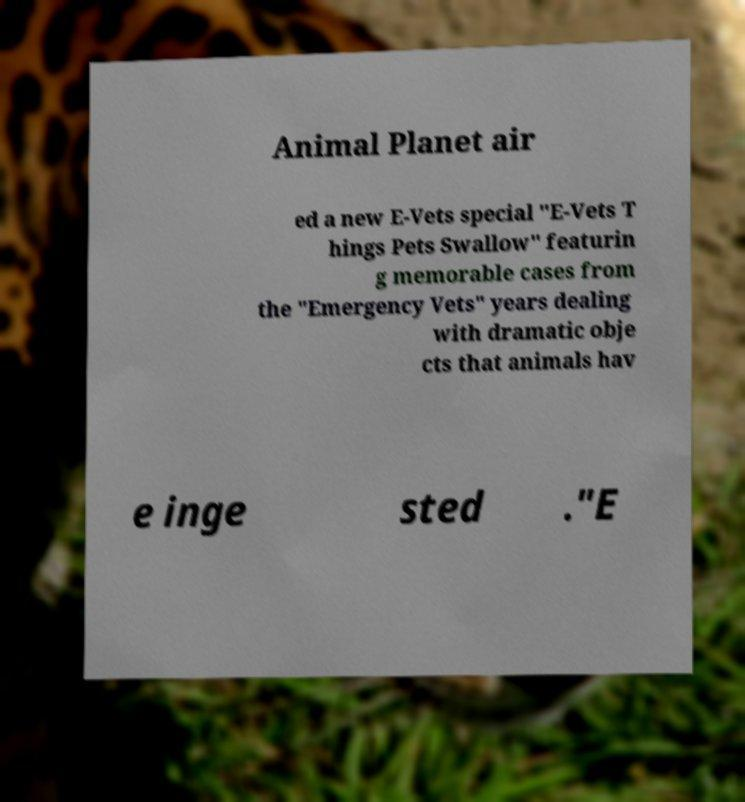I need the written content from this picture converted into text. Can you do that? Animal Planet air ed a new E-Vets special "E-Vets T hings Pets Swallow" featurin g memorable cases from the "Emergency Vets" years dealing with dramatic obje cts that animals hav e inge sted ."E 